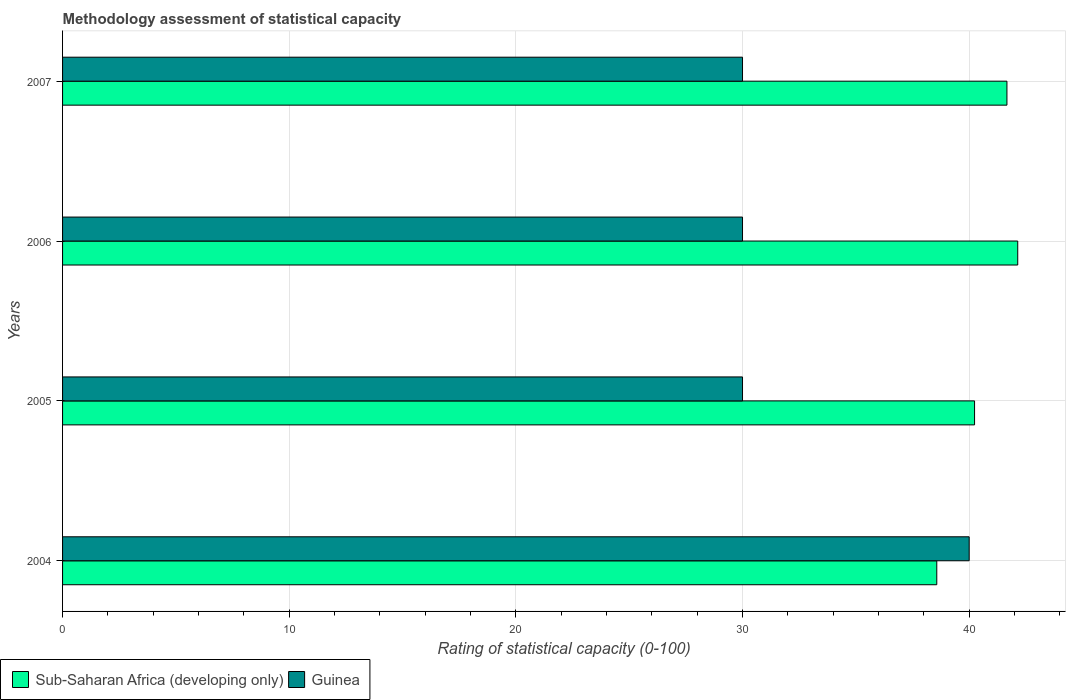How many different coloured bars are there?
Your answer should be very brief. 2. Are the number of bars per tick equal to the number of legend labels?
Keep it short and to the point. Yes. Are the number of bars on each tick of the Y-axis equal?
Your answer should be very brief. Yes. How many bars are there on the 1st tick from the bottom?
Keep it short and to the point. 2. In how many cases, is the number of bars for a given year not equal to the number of legend labels?
Provide a succinct answer. 0. What is the rating of statistical capacity in Guinea in 2005?
Ensure brevity in your answer.  30. Across all years, what is the maximum rating of statistical capacity in Sub-Saharan Africa (developing only)?
Provide a succinct answer. 42.14. Across all years, what is the minimum rating of statistical capacity in Sub-Saharan Africa (developing only)?
Provide a short and direct response. 38.57. In which year was the rating of statistical capacity in Guinea maximum?
Ensure brevity in your answer.  2004. In which year was the rating of statistical capacity in Sub-Saharan Africa (developing only) minimum?
Offer a terse response. 2004. What is the total rating of statistical capacity in Sub-Saharan Africa (developing only) in the graph?
Your answer should be compact. 162.62. What is the difference between the rating of statistical capacity in Sub-Saharan Africa (developing only) in 2006 and that in 2007?
Provide a succinct answer. 0.48. What is the difference between the rating of statistical capacity in Sub-Saharan Africa (developing only) in 2006 and the rating of statistical capacity in Guinea in 2007?
Your answer should be very brief. 12.14. What is the average rating of statistical capacity in Sub-Saharan Africa (developing only) per year?
Give a very brief answer. 40.65. In the year 2007, what is the difference between the rating of statistical capacity in Guinea and rating of statistical capacity in Sub-Saharan Africa (developing only)?
Your answer should be compact. -11.67. What is the ratio of the rating of statistical capacity in Guinea in 2004 to that in 2005?
Give a very brief answer. 1.33. What is the difference between the highest and the lowest rating of statistical capacity in Sub-Saharan Africa (developing only)?
Keep it short and to the point. 3.57. In how many years, is the rating of statistical capacity in Sub-Saharan Africa (developing only) greater than the average rating of statistical capacity in Sub-Saharan Africa (developing only) taken over all years?
Your response must be concise. 2. What does the 1st bar from the top in 2007 represents?
Your answer should be compact. Guinea. What does the 2nd bar from the bottom in 2005 represents?
Provide a succinct answer. Guinea. Are all the bars in the graph horizontal?
Offer a terse response. Yes. How many years are there in the graph?
Keep it short and to the point. 4. What is the difference between two consecutive major ticks on the X-axis?
Your response must be concise. 10. Where does the legend appear in the graph?
Your answer should be compact. Bottom left. How many legend labels are there?
Your answer should be compact. 2. What is the title of the graph?
Provide a short and direct response. Methodology assessment of statistical capacity. Does "Papua New Guinea" appear as one of the legend labels in the graph?
Offer a very short reply. No. What is the label or title of the X-axis?
Provide a short and direct response. Rating of statistical capacity (0-100). What is the Rating of statistical capacity (0-100) of Sub-Saharan Africa (developing only) in 2004?
Your response must be concise. 38.57. What is the Rating of statistical capacity (0-100) in Guinea in 2004?
Provide a short and direct response. 40. What is the Rating of statistical capacity (0-100) of Sub-Saharan Africa (developing only) in 2005?
Offer a very short reply. 40.24. What is the Rating of statistical capacity (0-100) in Guinea in 2005?
Offer a very short reply. 30. What is the Rating of statistical capacity (0-100) of Sub-Saharan Africa (developing only) in 2006?
Offer a terse response. 42.14. What is the Rating of statistical capacity (0-100) in Guinea in 2006?
Your answer should be compact. 30. What is the Rating of statistical capacity (0-100) in Sub-Saharan Africa (developing only) in 2007?
Ensure brevity in your answer.  41.67. Across all years, what is the maximum Rating of statistical capacity (0-100) of Sub-Saharan Africa (developing only)?
Provide a succinct answer. 42.14. Across all years, what is the minimum Rating of statistical capacity (0-100) in Sub-Saharan Africa (developing only)?
Keep it short and to the point. 38.57. Across all years, what is the minimum Rating of statistical capacity (0-100) of Guinea?
Provide a succinct answer. 30. What is the total Rating of statistical capacity (0-100) of Sub-Saharan Africa (developing only) in the graph?
Give a very brief answer. 162.62. What is the total Rating of statistical capacity (0-100) in Guinea in the graph?
Offer a terse response. 130. What is the difference between the Rating of statistical capacity (0-100) in Sub-Saharan Africa (developing only) in 2004 and that in 2005?
Give a very brief answer. -1.67. What is the difference between the Rating of statistical capacity (0-100) of Guinea in 2004 and that in 2005?
Your answer should be compact. 10. What is the difference between the Rating of statistical capacity (0-100) of Sub-Saharan Africa (developing only) in 2004 and that in 2006?
Ensure brevity in your answer.  -3.57. What is the difference between the Rating of statistical capacity (0-100) of Guinea in 2004 and that in 2006?
Your response must be concise. 10. What is the difference between the Rating of statistical capacity (0-100) in Sub-Saharan Africa (developing only) in 2004 and that in 2007?
Your answer should be very brief. -3.1. What is the difference between the Rating of statistical capacity (0-100) in Sub-Saharan Africa (developing only) in 2005 and that in 2006?
Provide a short and direct response. -1.9. What is the difference between the Rating of statistical capacity (0-100) of Guinea in 2005 and that in 2006?
Your answer should be compact. 0. What is the difference between the Rating of statistical capacity (0-100) in Sub-Saharan Africa (developing only) in 2005 and that in 2007?
Your answer should be compact. -1.43. What is the difference between the Rating of statistical capacity (0-100) in Guinea in 2005 and that in 2007?
Give a very brief answer. 0. What is the difference between the Rating of statistical capacity (0-100) of Sub-Saharan Africa (developing only) in 2006 and that in 2007?
Ensure brevity in your answer.  0.48. What is the difference between the Rating of statistical capacity (0-100) of Sub-Saharan Africa (developing only) in 2004 and the Rating of statistical capacity (0-100) of Guinea in 2005?
Make the answer very short. 8.57. What is the difference between the Rating of statistical capacity (0-100) of Sub-Saharan Africa (developing only) in 2004 and the Rating of statistical capacity (0-100) of Guinea in 2006?
Keep it short and to the point. 8.57. What is the difference between the Rating of statistical capacity (0-100) of Sub-Saharan Africa (developing only) in 2004 and the Rating of statistical capacity (0-100) of Guinea in 2007?
Your response must be concise. 8.57. What is the difference between the Rating of statistical capacity (0-100) of Sub-Saharan Africa (developing only) in 2005 and the Rating of statistical capacity (0-100) of Guinea in 2006?
Ensure brevity in your answer.  10.24. What is the difference between the Rating of statistical capacity (0-100) of Sub-Saharan Africa (developing only) in 2005 and the Rating of statistical capacity (0-100) of Guinea in 2007?
Provide a short and direct response. 10.24. What is the difference between the Rating of statistical capacity (0-100) of Sub-Saharan Africa (developing only) in 2006 and the Rating of statistical capacity (0-100) of Guinea in 2007?
Ensure brevity in your answer.  12.14. What is the average Rating of statistical capacity (0-100) of Sub-Saharan Africa (developing only) per year?
Your answer should be compact. 40.65. What is the average Rating of statistical capacity (0-100) of Guinea per year?
Your response must be concise. 32.5. In the year 2004, what is the difference between the Rating of statistical capacity (0-100) of Sub-Saharan Africa (developing only) and Rating of statistical capacity (0-100) of Guinea?
Give a very brief answer. -1.43. In the year 2005, what is the difference between the Rating of statistical capacity (0-100) in Sub-Saharan Africa (developing only) and Rating of statistical capacity (0-100) in Guinea?
Provide a short and direct response. 10.24. In the year 2006, what is the difference between the Rating of statistical capacity (0-100) of Sub-Saharan Africa (developing only) and Rating of statistical capacity (0-100) of Guinea?
Make the answer very short. 12.14. In the year 2007, what is the difference between the Rating of statistical capacity (0-100) in Sub-Saharan Africa (developing only) and Rating of statistical capacity (0-100) in Guinea?
Your answer should be very brief. 11.67. What is the ratio of the Rating of statistical capacity (0-100) of Sub-Saharan Africa (developing only) in 2004 to that in 2005?
Give a very brief answer. 0.96. What is the ratio of the Rating of statistical capacity (0-100) in Guinea in 2004 to that in 2005?
Provide a short and direct response. 1.33. What is the ratio of the Rating of statistical capacity (0-100) of Sub-Saharan Africa (developing only) in 2004 to that in 2006?
Make the answer very short. 0.92. What is the ratio of the Rating of statistical capacity (0-100) of Sub-Saharan Africa (developing only) in 2004 to that in 2007?
Your response must be concise. 0.93. What is the ratio of the Rating of statistical capacity (0-100) in Guinea in 2004 to that in 2007?
Make the answer very short. 1.33. What is the ratio of the Rating of statistical capacity (0-100) of Sub-Saharan Africa (developing only) in 2005 to that in 2006?
Offer a very short reply. 0.95. What is the ratio of the Rating of statistical capacity (0-100) in Sub-Saharan Africa (developing only) in 2005 to that in 2007?
Offer a very short reply. 0.97. What is the ratio of the Rating of statistical capacity (0-100) of Guinea in 2005 to that in 2007?
Provide a short and direct response. 1. What is the ratio of the Rating of statistical capacity (0-100) in Sub-Saharan Africa (developing only) in 2006 to that in 2007?
Provide a short and direct response. 1.01. What is the ratio of the Rating of statistical capacity (0-100) of Guinea in 2006 to that in 2007?
Your answer should be very brief. 1. What is the difference between the highest and the second highest Rating of statistical capacity (0-100) in Sub-Saharan Africa (developing only)?
Provide a short and direct response. 0.48. What is the difference between the highest and the second highest Rating of statistical capacity (0-100) of Guinea?
Your response must be concise. 10. What is the difference between the highest and the lowest Rating of statistical capacity (0-100) of Sub-Saharan Africa (developing only)?
Provide a succinct answer. 3.57. What is the difference between the highest and the lowest Rating of statistical capacity (0-100) in Guinea?
Your answer should be compact. 10. 